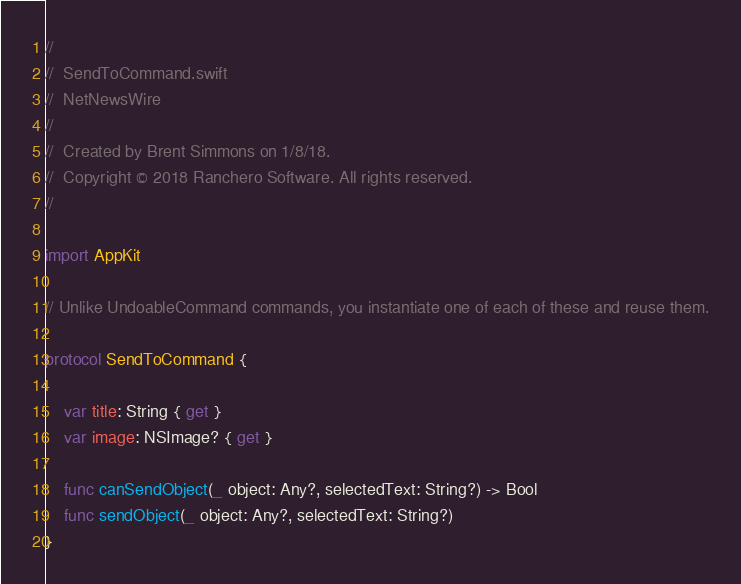Convert code to text. <code><loc_0><loc_0><loc_500><loc_500><_Swift_>//
//  SendToCommand.swift
//  NetNewsWire
//
//  Created by Brent Simmons on 1/8/18.
//  Copyright © 2018 Ranchero Software. All rights reserved.
//

import AppKit

// Unlike UndoableCommand commands, you instantiate one of each of these and reuse them.

protocol SendToCommand {

	var title: String { get }
	var image: NSImage? { get }

	func canSendObject(_ object: Any?, selectedText: String?) -> Bool
	func sendObject(_ object: Any?, selectedText: String?)
}

</code> 